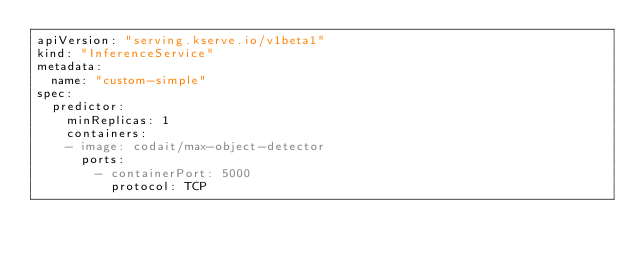<code> <loc_0><loc_0><loc_500><loc_500><_YAML_>apiVersion: "serving.kserve.io/v1beta1"
kind: "InferenceService"
metadata:
  name: "custom-simple"
spec:
  predictor:
    minReplicas: 1
    containers:
    - image: codait/max-object-detector
      ports:
        - containerPort: 5000
          protocol: TCP
</code> 